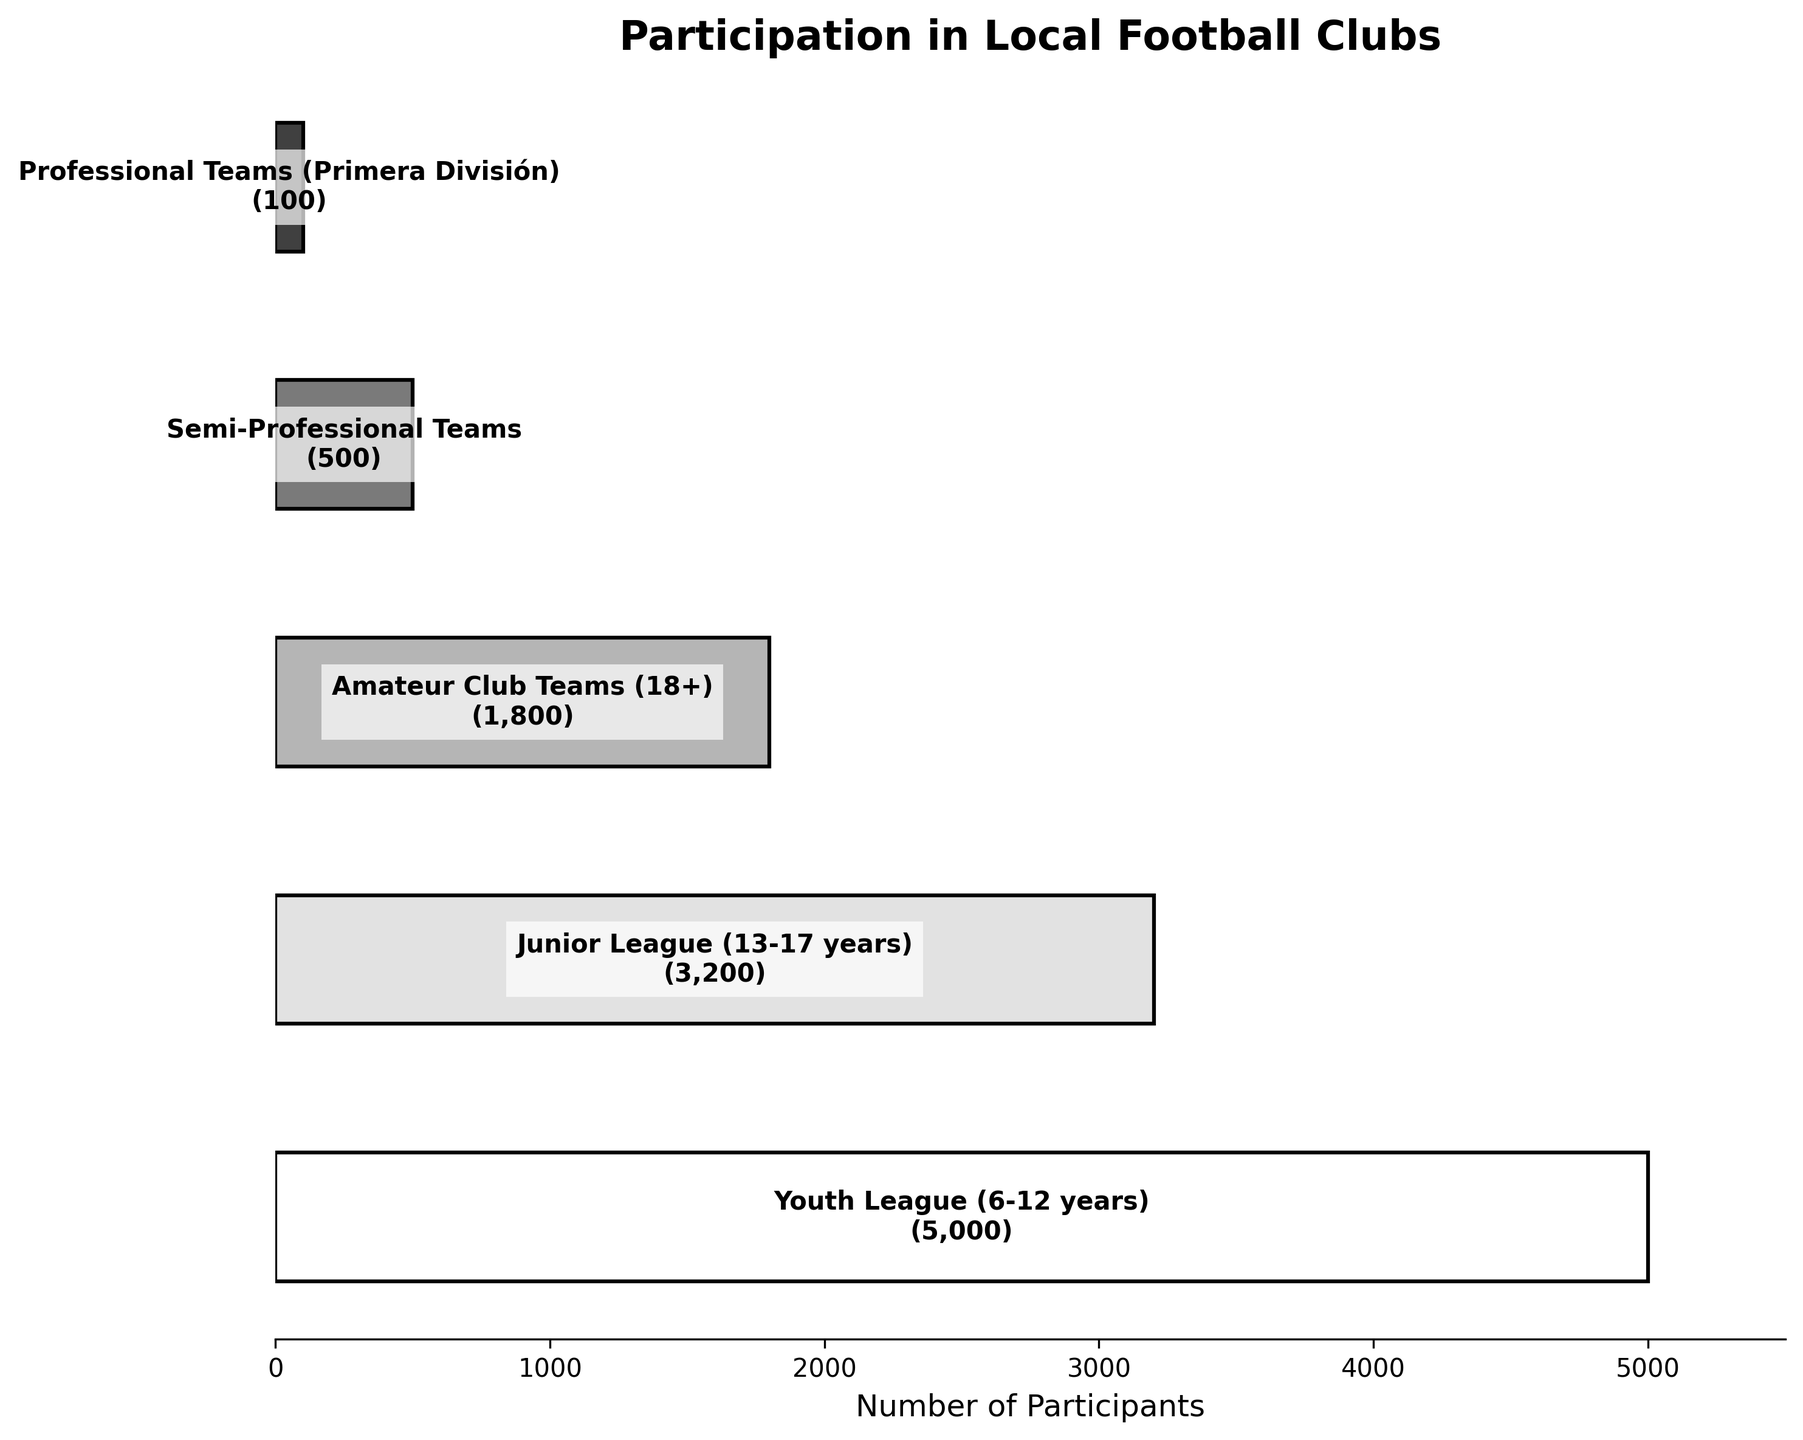What is the title of the chart? The title of the chart is usually displayed at the top. Look for the largest text that describes what the chart is about.
Answer: Participation in Local Football Clubs How many stages are presented in the chart? Count the number of distinct horizontal bars or sections in the funnel chart. Each bar represents a different stage.
Answer: 5 Which stage has the highest number of participants? Look for the widest bar or the largest number in the chart. This will indicate the stage with the most participants.
Answer: Youth League (6-12 years) How many participants are there in the Professional Teams (Primera División)? Find the section labeled "Professional Teams (Primera División)" and read the corresponding number of participants.
Answer: 100 What is the total number of participants in all the stages? Add the number of participants for each stage: 5000 (Youth League) + 3200 (Junior League) + 1800 (Amateur Club Teams) + 500 (Semi-Professional Teams) + 100 (Professional Teams).
Answer: 10,600 How many more participants are there in the Youth League compared to the Junior League? Subtract the number of participants in the Junior League from the number in the Youth League: 5000 - 3200.
Answer: 1800 What fraction of the total participants are in Amateur Club Teams? Divide the number of participants in Amateur Club Teams by the total number of participants, and express as a fraction: 1800/10600.
Answer: 0.17 (approximately) What is the difference in the number of participants between the Semi-Professional and Professional teams? Subtract the number of participants in the Professional Teams from the number in the Semi-Professional Teams: 500 - 100.
Answer: 400 Which stage experienced the greatest drop in participation from the previous stage? Calculate the difference between the number of participants in each stage and the previous stage, and find the largest drop: (5000-3200 = 1800), (3200-1800 = 1400), (1800-500 = 1300), (500-100 = 400).
Answer: Youth League to Junior League What percentage of participants are still actively involved from Youth League to Professional Teams? Divide the number of participants in the Professional Teams by the number in the Youth League, then multiply by 100 to get the percentage: (100/5000) * 100.
Answer: 2% 